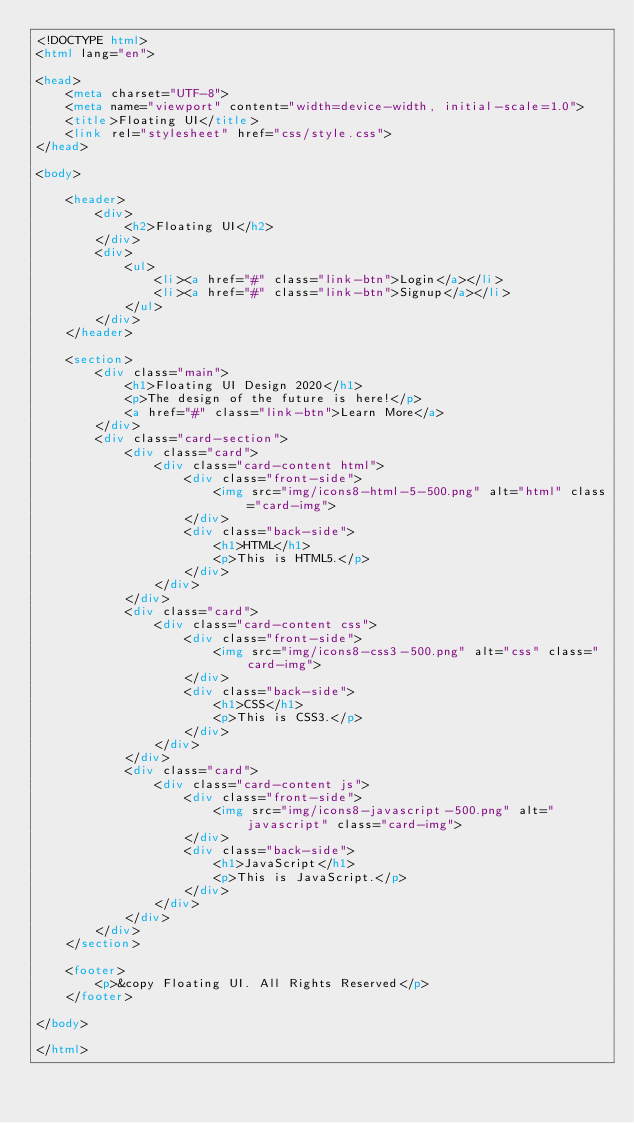<code> <loc_0><loc_0><loc_500><loc_500><_HTML_><!DOCTYPE html>
<html lang="en">

<head>
    <meta charset="UTF-8">
    <meta name="viewport" content="width=device-width, initial-scale=1.0">
    <title>Floating UI</title>
    <link rel="stylesheet" href="css/style.css">
</head>

<body>

    <header>
        <div>
            <h2>Floating UI</h2>
        </div>
        <div>
            <ul>
                <li><a href="#" class="link-btn">Login</a></li>
                <li><a href="#" class="link-btn">Signup</a></li>
            </ul>
        </div>
    </header>

    <section>
        <div class="main">
            <h1>Floating UI Design 2020</h1>
            <p>The design of the future is here!</p>
            <a href="#" class="link-btn">Learn More</a>
        </div>
        <div class="card-section">
            <div class="card">
                <div class="card-content html">
                    <div class="front-side">
                        <img src="img/icons8-html-5-500.png" alt="html" class="card-img">
                    </div>
                    <div class="back-side">
                        <h1>HTML</h1>
                        <p>This is HTML5.</p>
                    </div>
                </div>
            </div>
            <div class="card">
                <div class="card-content css">
                    <div class="front-side">
                        <img src="img/icons8-css3-500.png" alt="css" class="card-img">
                    </div>
                    <div class="back-side">
                        <h1>CSS</h1>
                        <p>This is CSS3.</p>
                    </div>
                </div>
            </div>
            <div class="card">
                <div class="card-content js">
                    <div class="front-side">
                        <img src="img/icons8-javascript-500.png" alt="javascript" class="card-img">
                    </div>
                    <div class="back-side">
                        <h1>JavaScript</h1>
                        <p>This is JavaScript.</p>
                    </div>
                </div>
            </div>
        </div>
    </section>

    <footer>
        <p>&copy Floating UI. All Rights Reserved</p>
    </footer>

</body>

</html></code> 